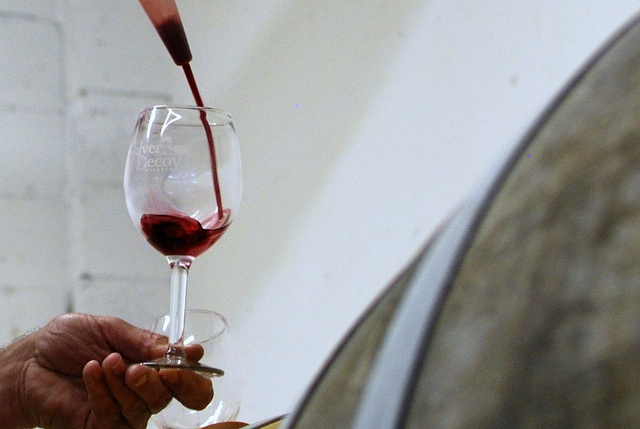Describe the objects in this image and their specific colors. I can see wine glass in darkgray, lightgray, black, and maroon tones, people in darkgray, black, maroon, and brown tones, and bottle in darkgray, black, brown, and maroon tones in this image. 